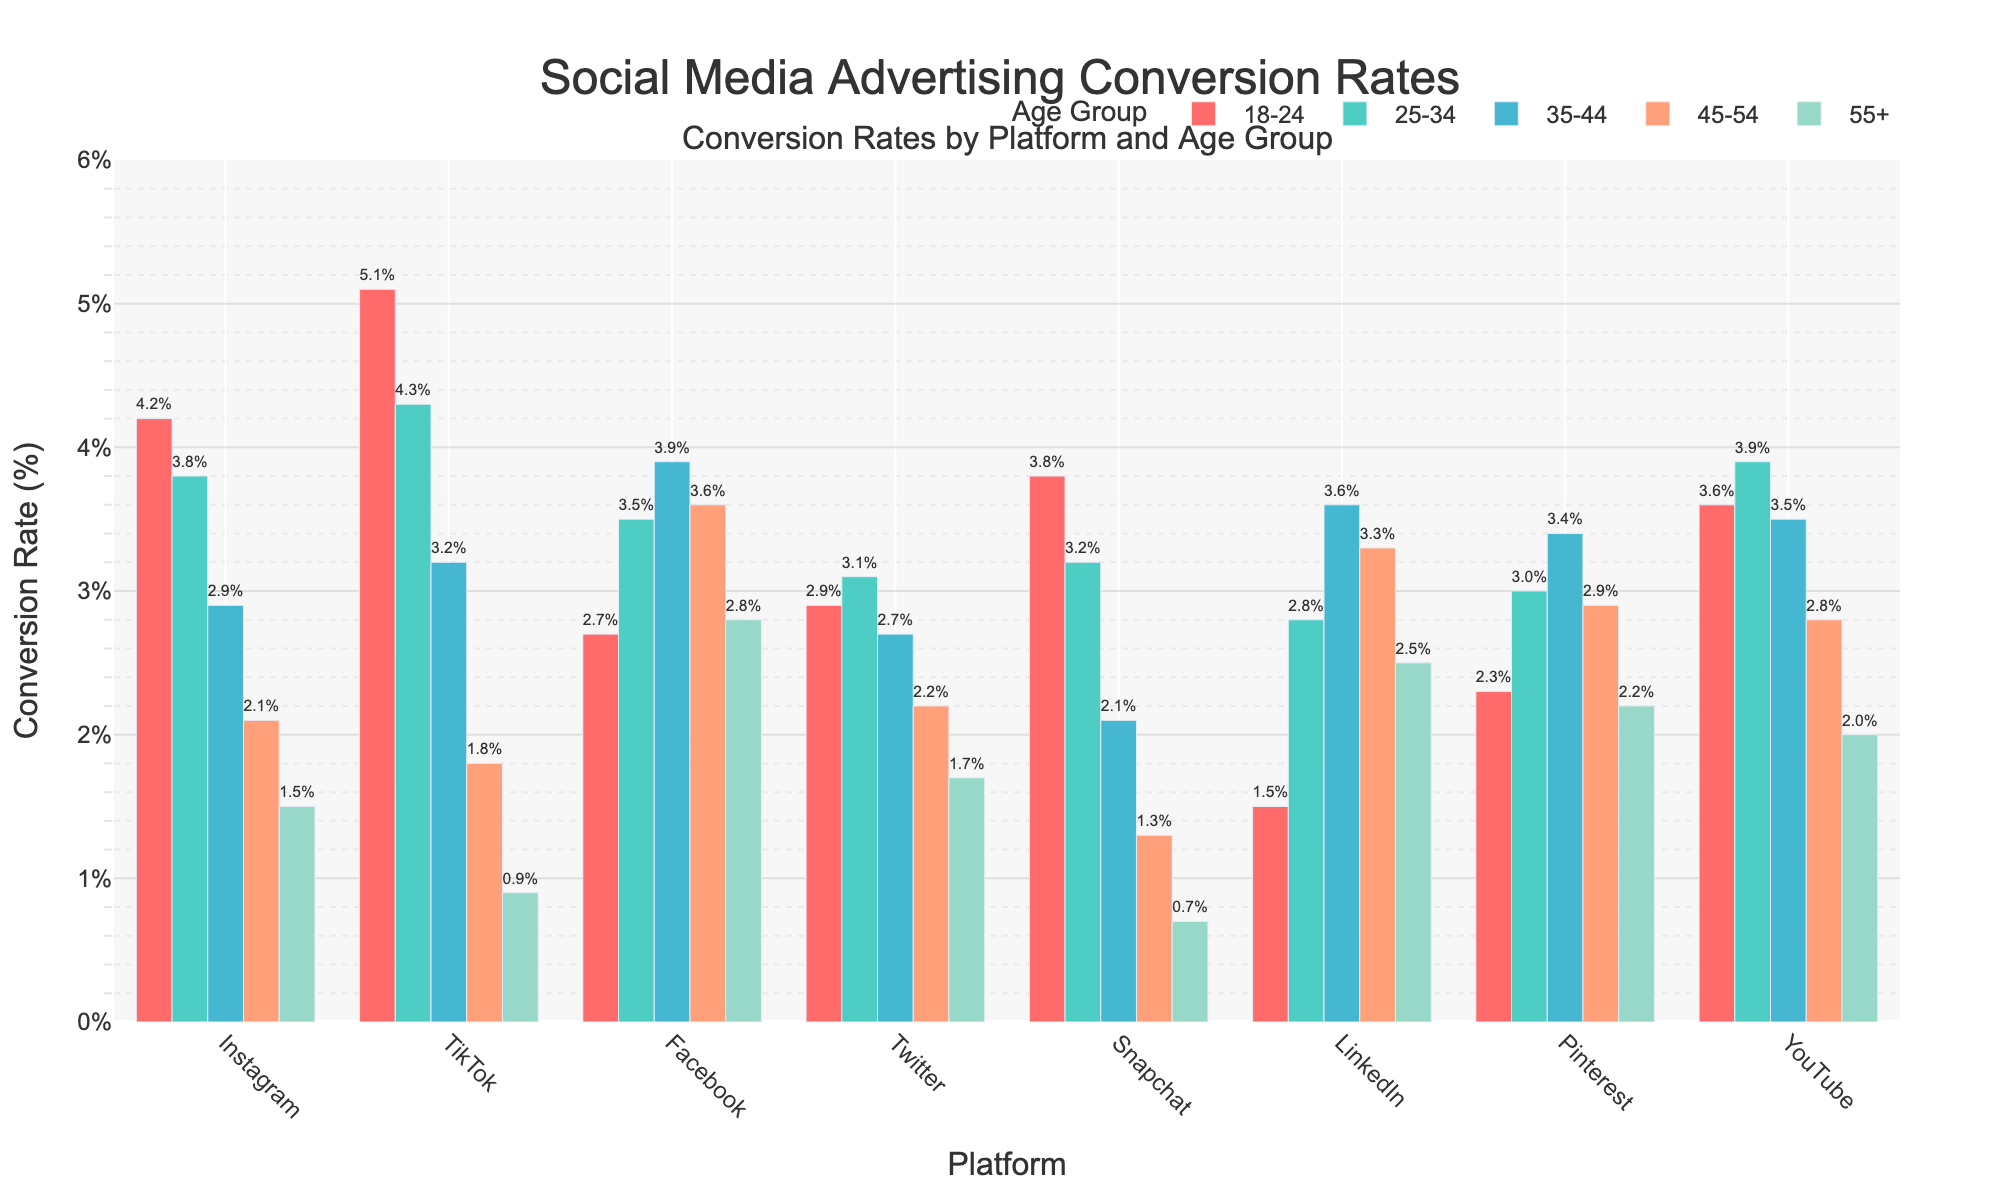Which platform has the highest conversion rate for the 18-24 age group? Look at the bars representing the 18-24 age group. The tallest bar in this group corresponds to TikTok.
Answer: TikTok How does the conversion rate for Instagram in the 18-24 age group compare to the 45-54 age group? Compare the heights of the bars for Instagram in the 18-24 and 45-54 age groups. The 18-24 bar is noticeably taller.
Answer: Higher Which age group has the highest conversion rate on LinkedIn? Look at the bars for LinkedIn and identify the tallest one. The tallest bar corresponds to the 35-44 age group.
Answer: 35-44 What is the difference in conversion rate between Snapchat and Twitter for the 25-34 age group? Find the bars for Snapchat and Twitter in the 25-34 age group. Snapchat has a conversion rate of 3.2%, and Twitter has 3.1%. Subtract the two values: 3.2% - 3.1% = 0.1%
Answer: 0.1% Which platform has a higher average conversion rate across all age groups: Facebook or YouTube? Calculate the average conversion rate by summing up the values for each age group and dividing by the number of age groups. For Facebook: (2.7 + 3.5 + 3.9 + 3.6 + 2.8)/5 = 3.3%. For YouTube: (3.6 + 3.9 + 3.5 + 2.8 + 2.0)/5 = 3.16%. Compare the two averages.
Answer: Facebook What is the total conversion rate for Pinterest across all age groups? Add the conversion rates for Pinterest across all age groups: 2.3% + 3.0% + 3.4% + 2.9% + 2.2% = 13.8%
Answer: 13.8% Is the conversion rate for Twitter generally increasing or decreasing with age? Look at the bars for Twitter across age groups. The bars decrease in height from the 25-34 to the 55+ age groups.
Answer: Decreasing Which age group has the smallest range of conversion rates across all platforms? Calculate the range (difference between the highest and lowest values) for each age group. The ranges are: 18-24: 5.1% - 1.5% = 3.6%; 25-34: 4.3% - 2.8% = 1.5%; 35-44: 3.9% - 2.1% = 1.8%; 45-54: 3.6% - 1.3% = 2.3%; 55+: 2.8% - 0.7% = 2.1%. The smallest range is 1.5% for the 25-34 age group.
Answer: 25-34 What is the average conversion rate for the 35-44 age group across all platforms? Add the conversion rates for the 35-44 age group across all platforms and divide by the number of platforms: (2.9% + 3.2% + 3.9% + 2.7% + 2.1% + 3.6% + 3.4% + 3.5%) / 8 = 3.16%
Answer: 3.16% Which platform shows the most significant decline in conversion rate across age groups from 18-24 to 55+? Calculate the decline for each platform by subtracting the conversion rate for 55+ from the rate for 18-24. The declines are: Instagram: 4.2% - 1.5% = 2.7%; TikTok: 5.1% - 0.9% = 4.2%; Facebook: 2.7% - 2.8% = -0.1%; Twitter: 2.9% - 1.7% = 1.2%; Snapchat: 3.8% - 0.7% = 3.1%; LinkedIn: 1.5% - 2.5% = -1.0%; Pinterest: 2.3% - 2.2% = 0.1%; YouTube: 3.6% - 2.0% = 1.6%. The most significant decline is 4.2% for TikTok.
Answer: TikTok 